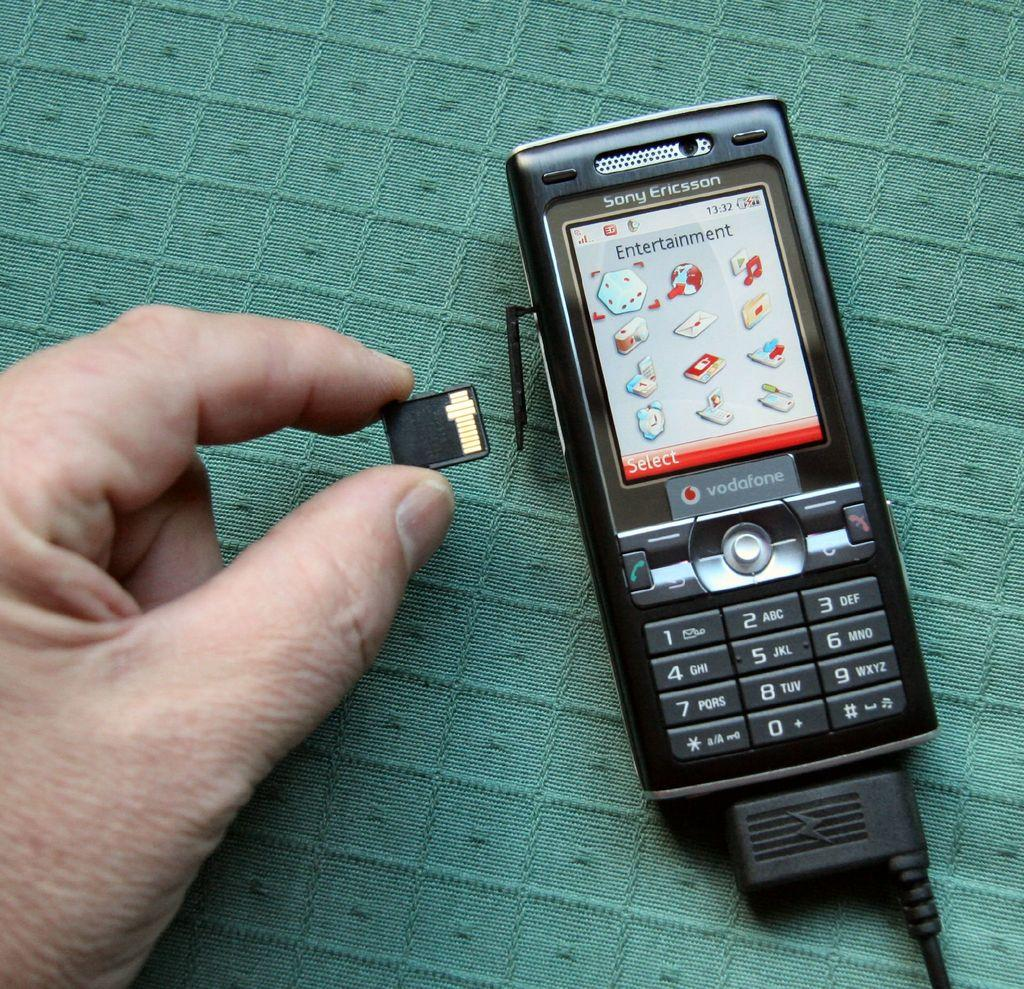<image>
Render a clear and concise summary of the photo. A vodofone cell phone sits on a green background. 